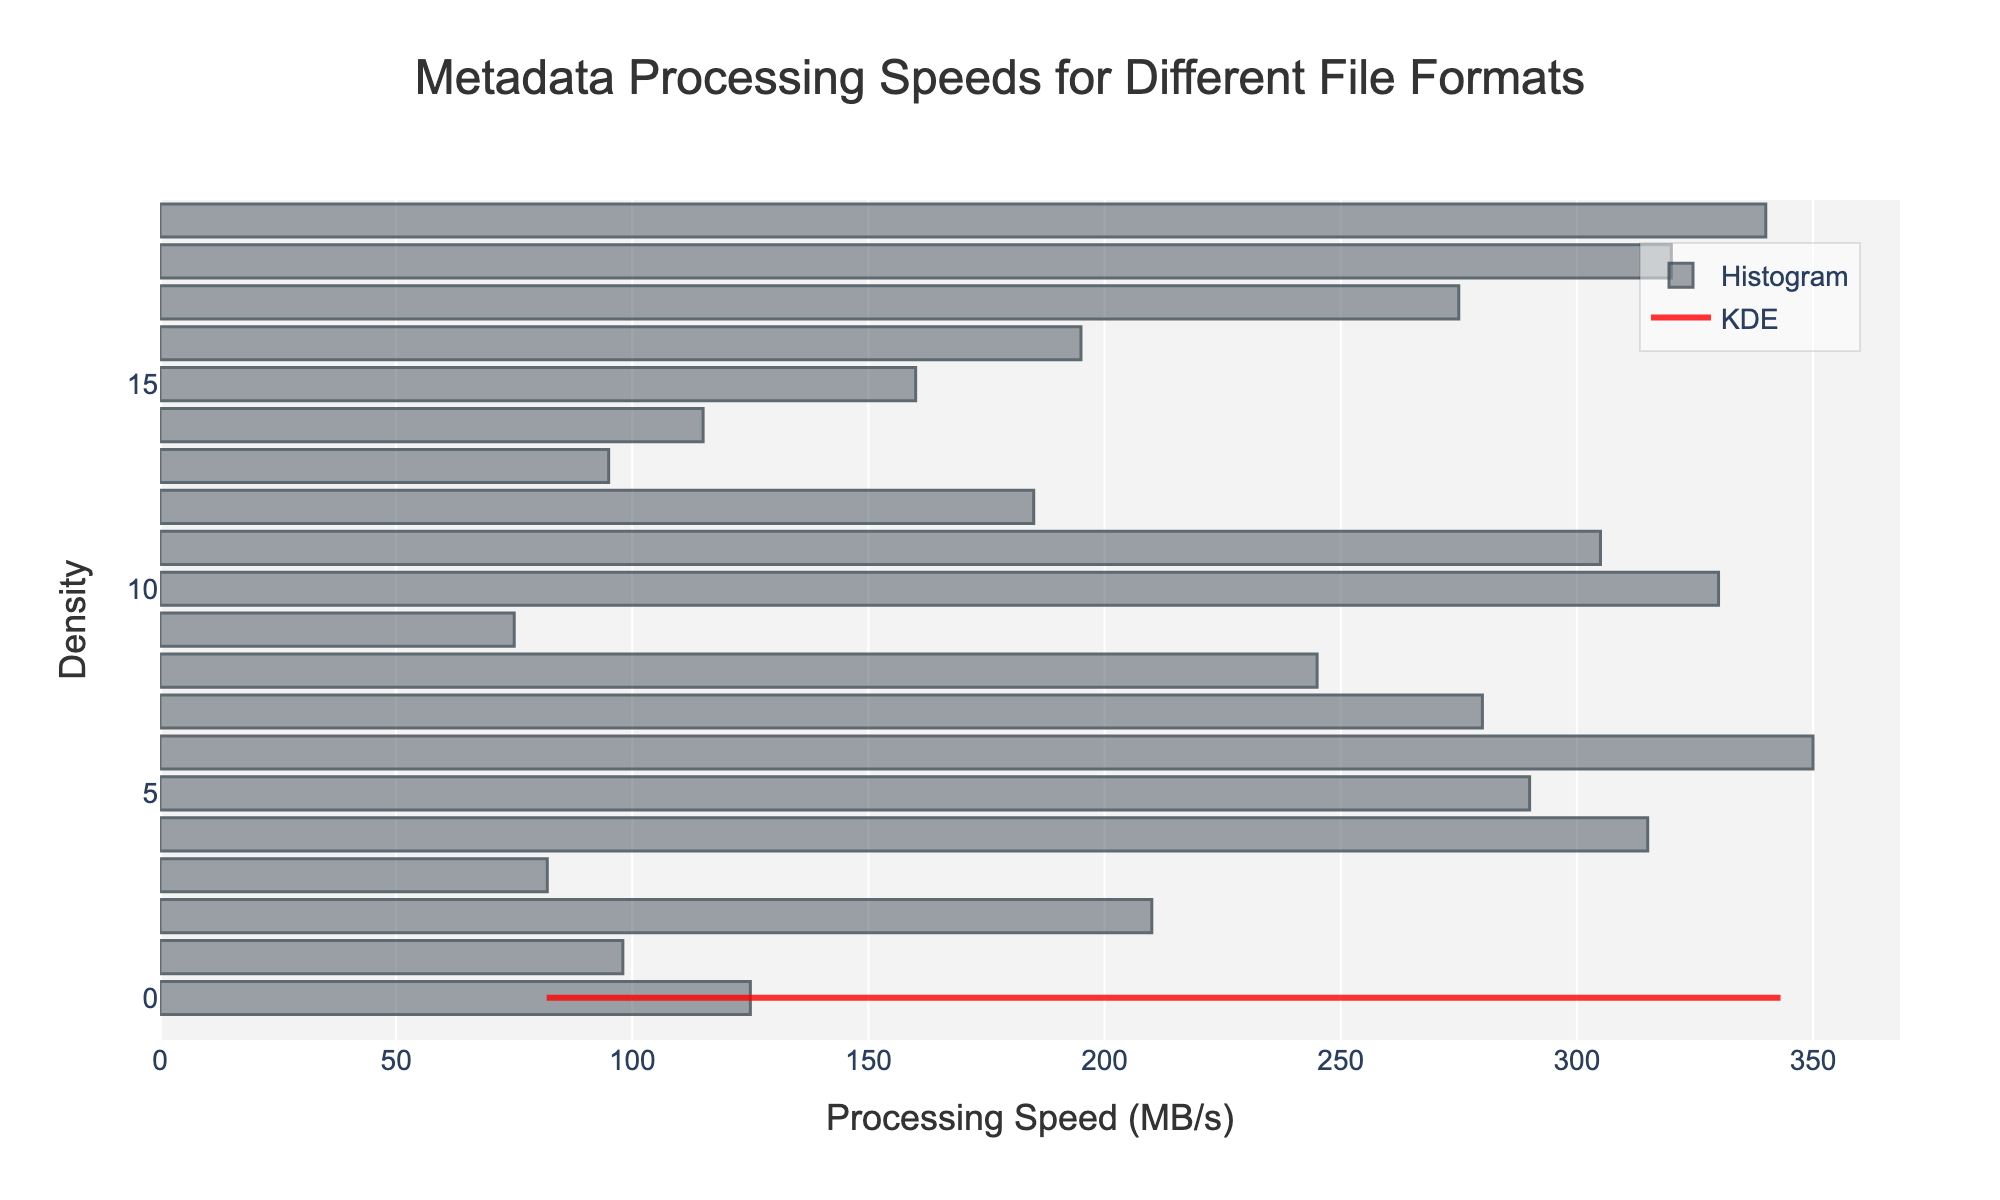What is the title of the figure? The title is located at the top of the figure and is easy to read. It summarizes the content of the graph.
Answer: Metadata Processing Speeds for Different File Formats What are the units used on the x-axis? The label of the x-axis provides information about the units used for measurement, making it clear what is being measured.
Answer: Processing Speed (MB/s) Which file format has the highest processing speed? The highest point in the histogram and the KDE curve indicates the file format with the maximum processing speed. The x-axis value at this point is the relevant processing speed.
Answer: Protocol Buffers What is the processing speed range for most file formats? The histogram bars that are the tallest indicate the range where most data points fall. Observing the x-axis values of these bars gives the processing speed range.
Answer: Between 200 MB/s and 350 MB/s How many file formats have a processing speed above 300 MB/s? Count the number of histogram bars to the right of the 300 MB/s mark. Each bar corresponds to a file format that falls within this speed range.
Answer: 4 What is the processing speed of the file format with the lowest KDE density? Identify the minimum point on the KDE curve and note the x-axis value at this point to determine the processing speed.
Answer: Around 75 MB/s How does the processing speed of Parquet compare to CSV? Look at the histogram bars for Parquet and CSV and compare their heights and x-axis positions. This will show if Parquet is faster, slower, or the same as CSV.
Answer: Parquet has a higher processing speed than CSV What is the average processing speed of file formats? To find the average, sum the processing speeds of all file formats and divide by the number of data points. This requires looking at each bar's position and corresponding value. Given data: JSON, XML, CSV, YAML, Parquet, Avro, Protocol_Buffers, ORC, HDF5, RDF, Feather, MessagePack, BSON, TOML, INI, Excel, SQLite, Thrift, Capn_Proto, FlatBuffers
Answer: Approximately 220 MB/s Which file formats have processing speeds below 100 MB/s? Identify the bars to the left of the 100 MB/s mark on the histogram and list the corresponding file formats.
Answer: YAML, XML, RDF, TOML What is the peak density value in the KDE curve, and what processing speed does it correspond to? Locate the highest point on the KDE curve and note its y-axis value and the corresponding x-axis processing speed.
Answer: Peak density value is around 0.03 at approximately 315 MB/s 